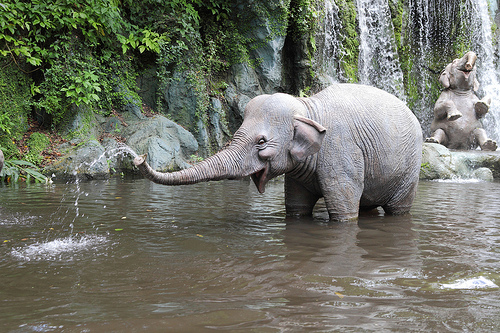Reflect on the possible location where this image might have been taken. The setting suggests a tropical or subtropical region, perhaps a sanctuary, national park, or a natural reserve dedicated to wildlife conservation where elephants can roam freely and have access to natural water sources. 